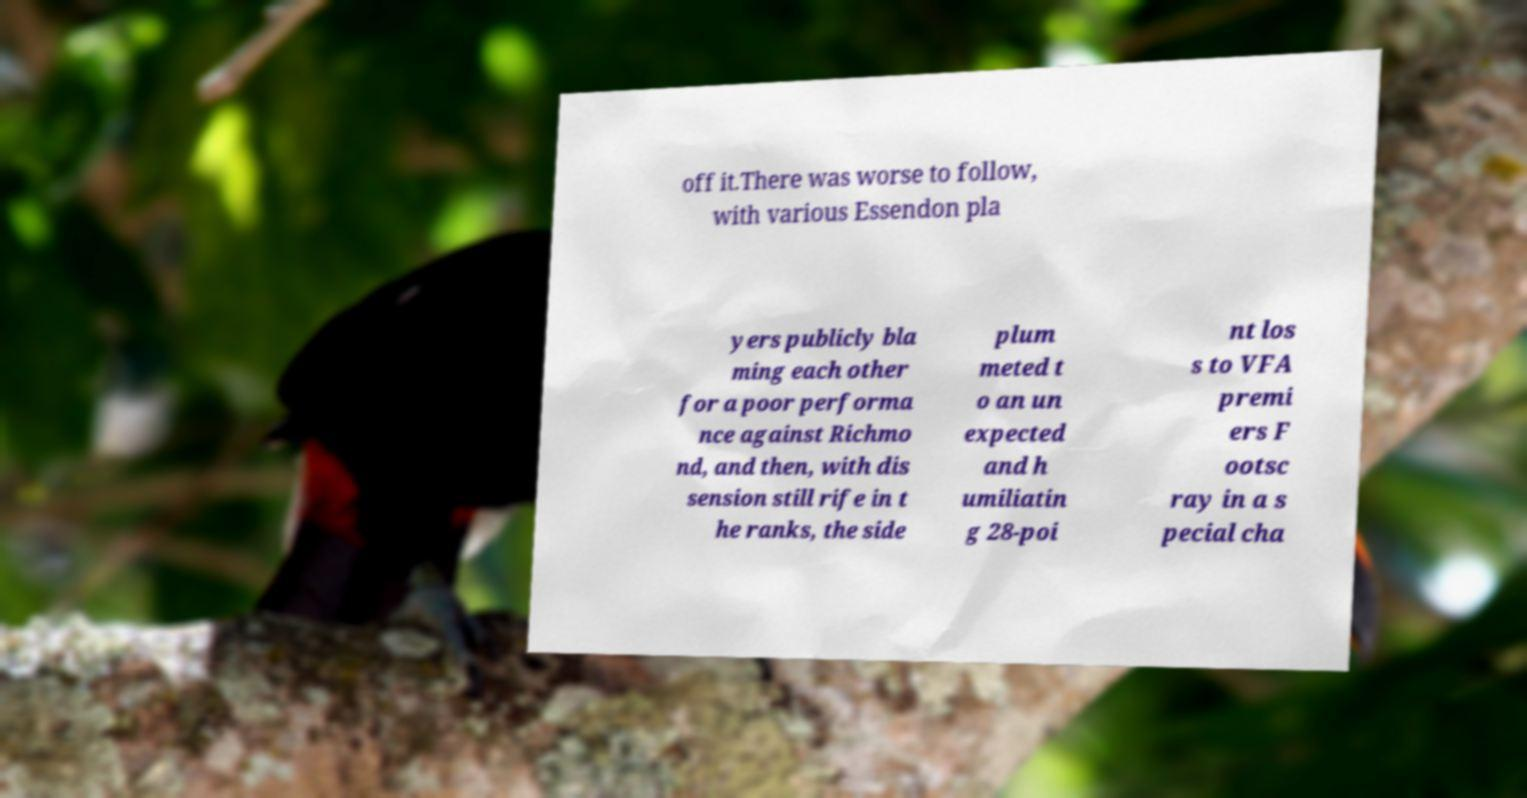Could you assist in decoding the text presented in this image and type it out clearly? off it.There was worse to follow, with various Essendon pla yers publicly bla ming each other for a poor performa nce against Richmo nd, and then, with dis sension still rife in t he ranks, the side plum meted t o an un expected and h umiliatin g 28-poi nt los s to VFA premi ers F ootsc ray in a s pecial cha 